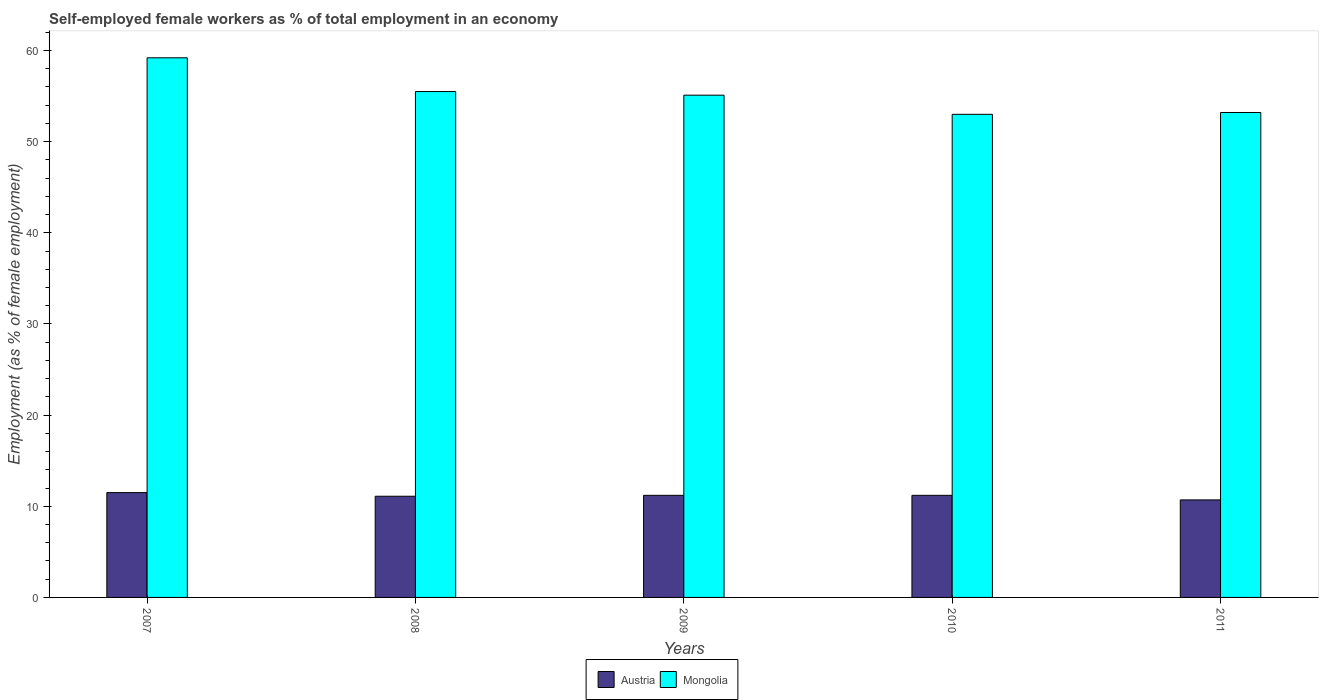How many groups of bars are there?
Ensure brevity in your answer.  5. Are the number of bars per tick equal to the number of legend labels?
Offer a very short reply. Yes. Are the number of bars on each tick of the X-axis equal?
Give a very brief answer. Yes. How many bars are there on the 5th tick from the right?
Offer a very short reply. 2. What is the label of the 2nd group of bars from the left?
Give a very brief answer. 2008. In how many cases, is the number of bars for a given year not equal to the number of legend labels?
Offer a very short reply. 0. What is the percentage of self-employed female workers in Mongolia in 2008?
Your response must be concise. 55.5. Across all years, what is the maximum percentage of self-employed female workers in Austria?
Your response must be concise. 11.5. Across all years, what is the minimum percentage of self-employed female workers in Austria?
Offer a very short reply. 10.7. In which year was the percentage of self-employed female workers in Mongolia minimum?
Make the answer very short. 2010. What is the total percentage of self-employed female workers in Austria in the graph?
Ensure brevity in your answer.  55.7. What is the difference between the percentage of self-employed female workers in Austria in 2007 and that in 2009?
Provide a short and direct response. 0.3. What is the difference between the percentage of self-employed female workers in Austria in 2011 and the percentage of self-employed female workers in Mongolia in 2010?
Your response must be concise. -42.3. What is the average percentage of self-employed female workers in Austria per year?
Your answer should be very brief. 11.14. In the year 2009, what is the difference between the percentage of self-employed female workers in Mongolia and percentage of self-employed female workers in Austria?
Make the answer very short. 43.9. In how many years, is the percentage of self-employed female workers in Mongolia greater than 52 %?
Provide a short and direct response. 5. What is the ratio of the percentage of self-employed female workers in Austria in 2010 to that in 2011?
Make the answer very short. 1.05. What is the difference between the highest and the second highest percentage of self-employed female workers in Mongolia?
Offer a terse response. 3.7. What is the difference between the highest and the lowest percentage of self-employed female workers in Austria?
Offer a very short reply. 0.8. Is the sum of the percentage of self-employed female workers in Austria in 2010 and 2011 greater than the maximum percentage of self-employed female workers in Mongolia across all years?
Provide a succinct answer. No. What does the 2nd bar from the left in 2010 represents?
Provide a succinct answer. Mongolia. What does the 1st bar from the right in 2010 represents?
Keep it short and to the point. Mongolia. Are all the bars in the graph horizontal?
Your answer should be compact. No. How many years are there in the graph?
Keep it short and to the point. 5. Are the values on the major ticks of Y-axis written in scientific E-notation?
Give a very brief answer. No. How are the legend labels stacked?
Your answer should be very brief. Horizontal. What is the title of the graph?
Offer a very short reply. Self-employed female workers as % of total employment in an economy. Does "Somalia" appear as one of the legend labels in the graph?
Your answer should be compact. No. What is the label or title of the X-axis?
Give a very brief answer. Years. What is the label or title of the Y-axis?
Your answer should be compact. Employment (as % of female employment). What is the Employment (as % of female employment) of Mongolia in 2007?
Your answer should be very brief. 59.2. What is the Employment (as % of female employment) of Austria in 2008?
Your answer should be very brief. 11.1. What is the Employment (as % of female employment) of Mongolia in 2008?
Offer a very short reply. 55.5. What is the Employment (as % of female employment) of Austria in 2009?
Your answer should be compact. 11.2. What is the Employment (as % of female employment) in Mongolia in 2009?
Give a very brief answer. 55.1. What is the Employment (as % of female employment) in Austria in 2010?
Offer a very short reply. 11.2. What is the Employment (as % of female employment) of Mongolia in 2010?
Your answer should be very brief. 53. What is the Employment (as % of female employment) in Austria in 2011?
Give a very brief answer. 10.7. What is the Employment (as % of female employment) of Mongolia in 2011?
Your answer should be very brief. 53.2. Across all years, what is the maximum Employment (as % of female employment) of Austria?
Your response must be concise. 11.5. Across all years, what is the maximum Employment (as % of female employment) in Mongolia?
Your answer should be very brief. 59.2. Across all years, what is the minimum Employment (as % of female employment) in Austria?
Offer a terse response. 10.7. Across all years, what is the minimum Employment (as % of female employment) in Mongolia?
Your response must be concise. 53. What is the total Employment (as % of female employment) in Austria in the graph?
Give a very brief answer. 55.7. What is the total Employment (as % of female employment) in Mongolia in the graph?
Ensure brevity in your answer.  276. What is the difference between the Employment (as % of female employment) of Austria in 2007 and that in 2009?
Your answer should be compact. 0.3. What is the difference between the Employment (as % of female employment) of Mongolia in 2007 and that in 2010?
Keep it short and to the point. 6.2. What is the difference between the Employment (as % of female employment) of Austria in 2007 and that in 2011?
Provide a short and direct response. 0.8. What is the difference between the Employment (as % of female employment) in Mongolia in 2007 and that in 2011?
Offer a very short reply. 6. What is the difference between the Employment (as % of female employment) in Austria in 2008 and that in 2009?
Provide a succinct answer. -0.1. What is the difference between the Employment (as % of female employment) of Austria in 2008 and that in 2010?
Your answer should be very brief. -0.1. What is the difference between the Employment (as % of female employment) in Mongolia in 2008 and that in 2010?
Provide a succinct answer. 2.5. What is the difference between the Employment (as % of female employment) of Austria in 2008 and that in 2011?
Offer a terse response. 0.4. What is the difference between the Employment (as % of female employment) in Mongolia in 2008 and that in 2011?
Ensure brevity in your answer.  2.3. What is the difference between the Employment (as % of female employment) of Mongolia in 2009 and that in 2011?
Keep it short and to the point. 1.9. What is the difference between the Employment (as % of female employment) of Austria in 2010 and that in 2011?
Make the answer very short. 0.5. What is the difference between the Employment (as % of female employment) in Austria in 2007 and the Employment (as % of female employment) in Mongolia in 2008?
Give a very brief answer. -44. What is the difference between the Employment (as % of female employment) of Austria in 2007 and the Employment (as % of female employment) of Mongolia in 2009?
Your response must be concise. -43.6. What is the difference between the Employment (as % of female employment) of Austria in 2007 and the Employment (as % of female employment) of Mongolia in 2010?
Provide a succinct answer. -41.5. What is the difference between the Employment (as % of female employment) of Austria in 2007 and the Employment (as % of female employment) of Mongolia in 2011?
Make the answer very short. -41.7. What is the difference between the Employment (as % of female employment) in Austria in 2008 and the Employment (as % of female employment) in Mongolia in 2009?
Offer a very short reply. -44. What is the difference between the Employment (as % of female employment) in Austria in 2008 and the Employment (as % of female employment) in Mongolia in 2010?
Offer a very short reply. -41.9. What is the difference between the Employment (as % of female employment) of Austria in 2008 and the Employment (as % of female employment) of Mongolia in 2011?
Your answer should be very brief. -42.1. What is the difference between the Employment (as % of female employment) in Austria in 2009 and the Employment (as % of female employment) in Mongolia in 2010?
Your response must be concise. -41.8. What is the difference between the Employment (as % of female employment) in Austria in 2009 and the Employment (as % of female employment) in Mongolia in 2011?
Keep it short and to the point. -42. What is the difference between the Employment (as % of female employment) of Austria in 2010 and the Employment (as % of female employment) of Mongolia in 2011?
Your answer should be compact. -42. What is the average Employment (as % of female employment) of Austria per year?
Provide a succinct answer. 11.14. What is the average Employment (as % of female employment) in Mongolia per year?
Give a very brief answer. 55.2. In the year 2007, what is the difference between the Employment (as % of female employment) of Austria and Employment (as % of female employment) of Mongolia?
Provide a short and direct response. -47.7. In the year 2008, what is the difference between the Employment (as % of female employment) of Austria and Employment (as % of female employment) of Mongolia?
Your answer should be compact. -44.4. In the year 2009, what is the difference between the Employment (as % of female employment) in Austria and Employment (as % of female employment) in Mongolia?
Offer a terse response. -43.9. In the year 2010, what is the difference between the Employment (as % of female employment) in Austria and Employment (as % of female employment) in Mongolia?
Your response must be concise. -41.8. In the year 2011, what is the difference between the Employment (as % of female employment) in Austria and Employment (as % of female employment) in Mongolia?
Offer a very short reply. -42.5. What is the ratio of the Employment (as % of female employment) of Austria in 2007 to that in 2008?
Your answer should be very brief. 1.04. What is the ratio of the Employment (as % of female employment) in Mongolia in 2007 to that in 2008?
Provide a succinct answer. 1.07. What is the ratio of the Employment (as % of female employment) in Austria in 2007 to that in 2009?
Your response must be concise. 1.03. What is the ratio of the Employment (as % of female employment) in Mongolia in 2007 to that in 2009?
Your answer should be compact. 1.07. What is the ratio of the Employment (as % of female employment) of Austria in 2007 to that in 2010?
Make the answer very short. 1.03. What is the ratio of the Employment (as % of female employment) of Mongolia in 2007 to that in 2010?
Provide a short and direct response. 1.12. What is the ratio of the Employment (as % of female employment) in Austria in 2007 to that in 2011?
Ensure brevity in your answer.  1.07. What is the ratio of the Employment (as % of female employment) in Mongolia in 2007 to that in 2011?
Ensure brevity in your answer.  1.11. What is the ratio of the Employment (as % of female employment) in Austria in 2008 to that in 2009?
Make the answer very short. 0.99. What is the ratio of the Employment (as % of female employment) of Mongolia in 2008 to that in 2009?
Offer a terse response. 1.01. What is the ratio of the Employment (as % of female employment) of Austria in 2008 to that in 2010?
Your answer should be very brief. 0.99. What is the ratio of the Employment (as % of female employment) of Mongolia in 2008 to that in 2010?
Offer a very short reply. 1.05. What is the ratio of the Employment (as % of female employment) in Austria in 2008 to that in 2011?
Provide a succinct answer. 1.04. What is the ratio of the Employment (as % of female employment) in Mongolia in 2008 to that in 2011?
Your answer should be compact. 1.04. What is the ratio of the Employment (as % of female employment) of Mongolia in 2009 to that in 2010?
Your answer should be compact. 1.04. What is the ratio of the Employment (as % of female employment) of Austria in 2009 to that in 2011?
Keep it short and to the point. 1.05. What is the ratio of the Employment (as % of female employment) of Mongolia in 2009 to that in 2011?
Make the answer very short. 1.04. What is the ratio of the Employment (as % of female employment) in Austria in 2010 to that in 2011?
Offer a very short reply. 1.05. What is the difference between the highest and the lowest Employment (as % of female employment) of Mongolia?
Your answer should be compact. 6.2. 